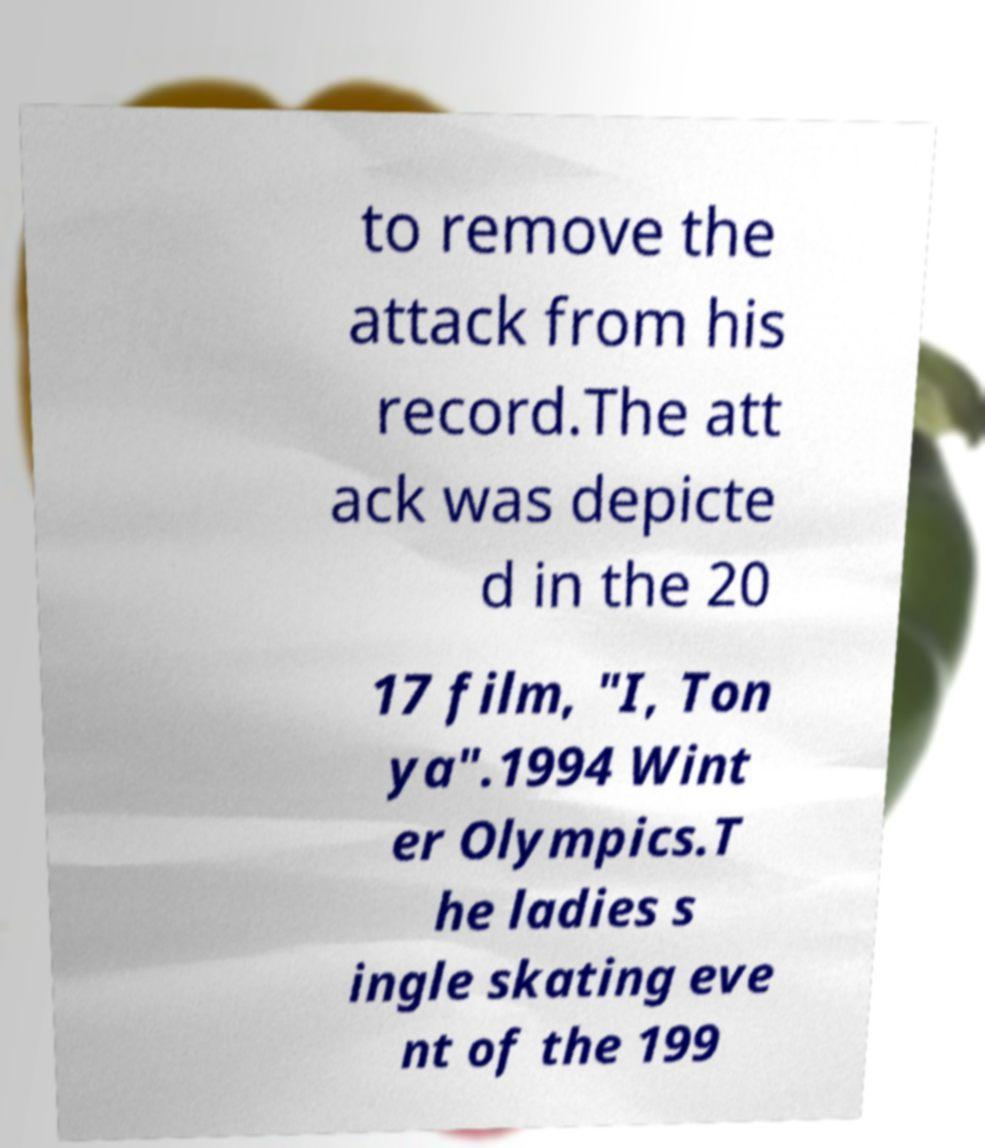Could you assist in decoding the text presented in this image and type it out clearly? to remove the attack from his record.The att ack was depicte d in the 20 17 film, "I, Ton ya".1994 Wint er Olympics.T he ladies s ingle skating eve nt of the 199 